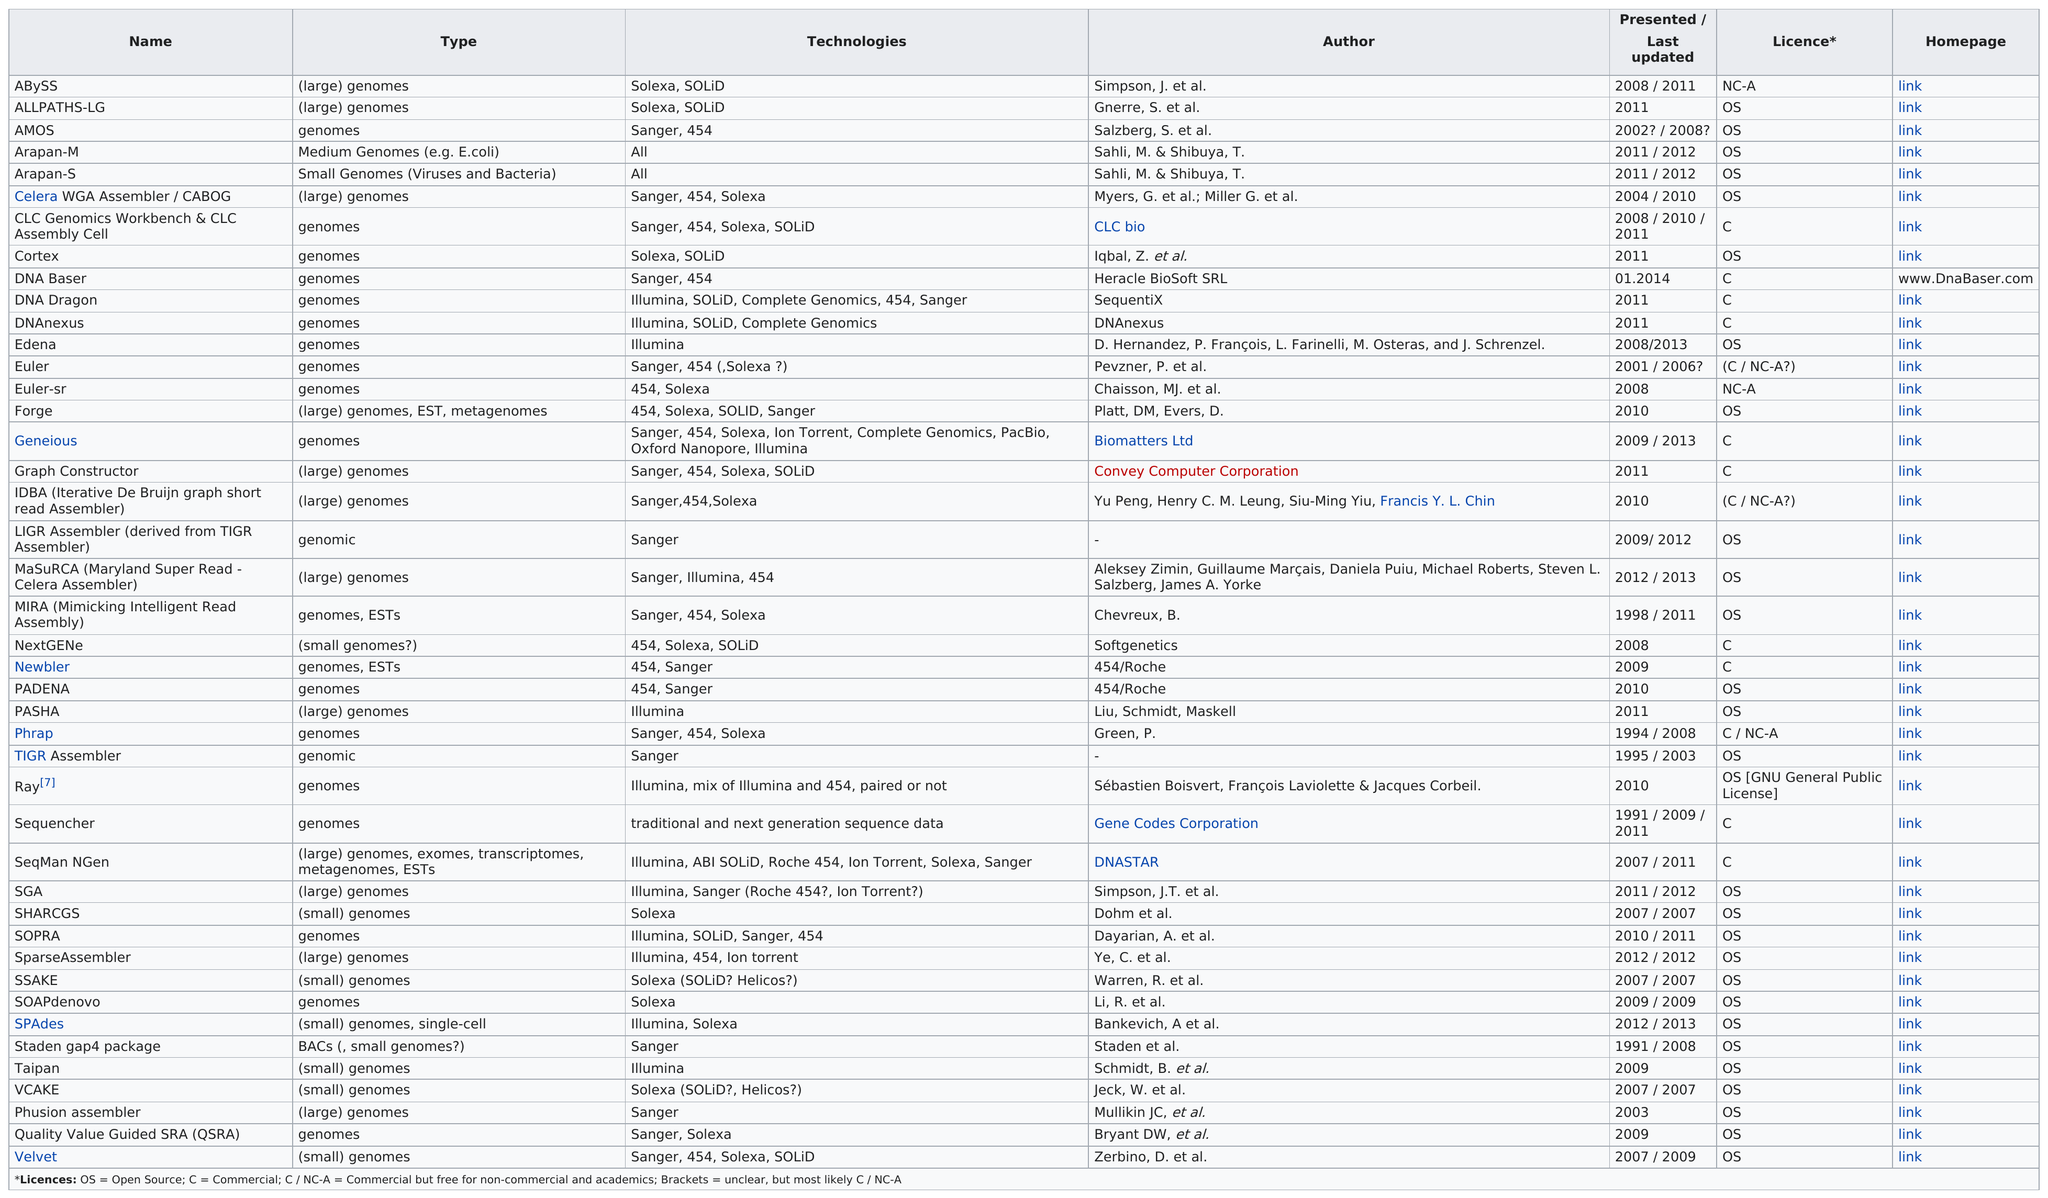Draw attention to some important aspects in this diagram. The operating system is listed more frequently than the C programming language. The Velvet was last updated in 2009. What is the most recent presentation or updated information regarding DNA Baser? There is only one assembler that supports medium-sized genomes. The total number of times Sahi, M., and Shilbuya, T. were listed as co-authors was two. 